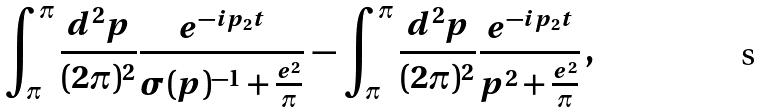Convert formula to latex. <formula><loc_0><loc_0><loc_500><loc_500>\int _ { \pi } ^ { \pi } \frac { d ^ { 2 } p } { ( 2 \pi ) ^ { 2 } } \frac { e ^ { - i p _ { 2 } t } } { \sigma ( p ) ^ { - 1 } + \frac { e ^ { 2 } } { \pi } } \, - \, \int _ { \pi } ^ { \pi } \frac { d ^ { 2 } p } { ( 2 \pi ) ^ { 2 } } \frac { e ^ { - i p _ { 2 } t } } { p ^ { 2 } + \frac { e ^ { 2 } } { \pi } } \, ,</formula> 